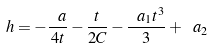Convert formula to latex. <formula><loc_0><loc_0><loc_500><loc_500>h = - \frac { \ a } { 4 t } - \frac { t } { 2 C } - \frac { \ a _ { 1 } t ^ { 3 } } { 3 } + \ a _ { 2 }</formula> 